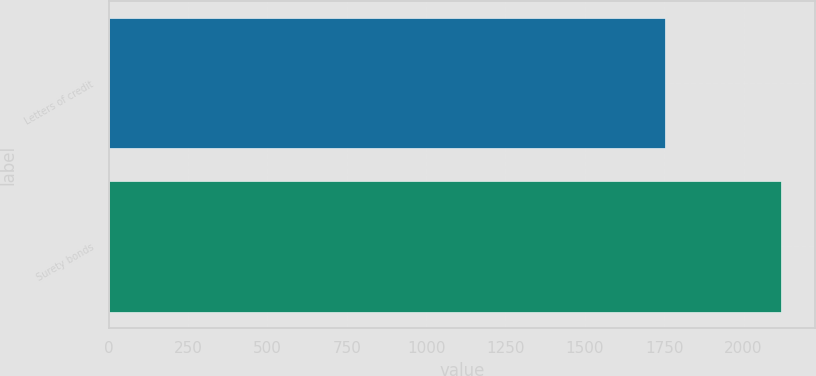Convert chart to OTSL. <chart><loc_0><loc_0><loc_500><loc_500><bar_chart><fcel>Letters of credit<fcel>Surety bonds<nl><fcel>1753.1<fcel>2119.2<nl></chart> 